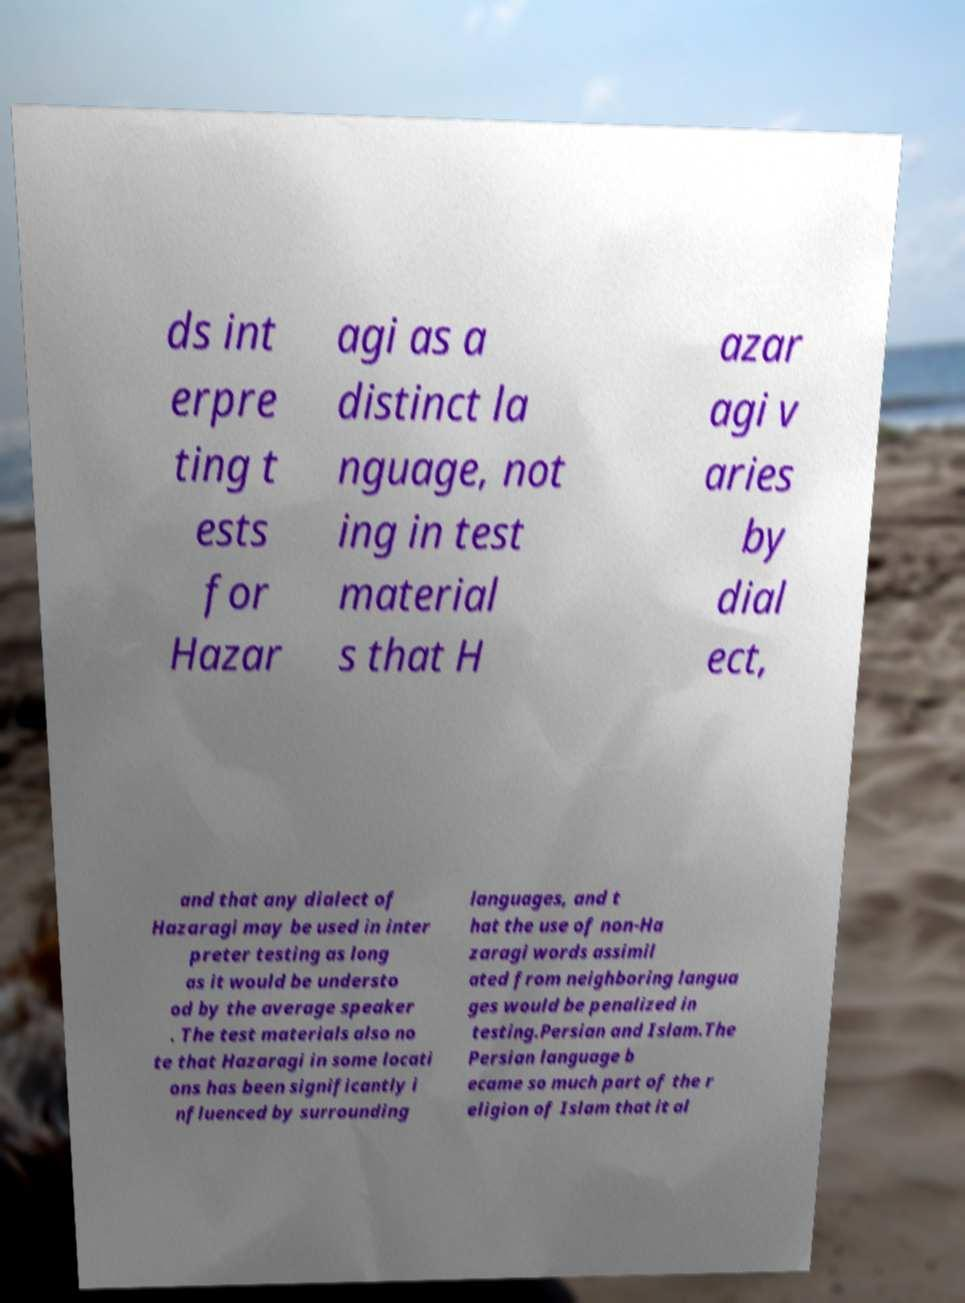There's text embedded in this image that I need extracted. Can you transcribe it verbatim? ds int erpre ting t ests for Hazar agi as a distinct la nguage, not ing in test material s that H azar agi v aries by dial ect, and that any dialect of Hazaragi may be used in inter preter testing as long as it would be understo od by the average speaker . The test materials also no te that Hazaragi in some locati ons has been significantly i nfluenced by surrounding languages, and t hat the use of non-Ha zaragi words assimil ated from neighboring langua ges would be penalized in testing.Persian and Islam.The Persian language b ecame so much part of the r eligion of Islam that it al 